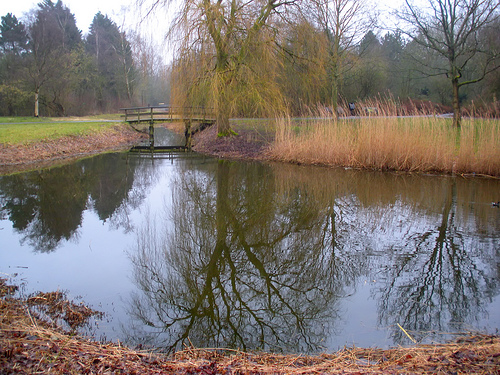<image>
Is the reflection under the tree? Yes. The reflection is positioned underneath the tree, with the tree above it in the vertical space. Is the tree on the lake? No. The tree is not positioned on the lake. They may be near each other, but the tree is not supported by or resting on top of the lake. 